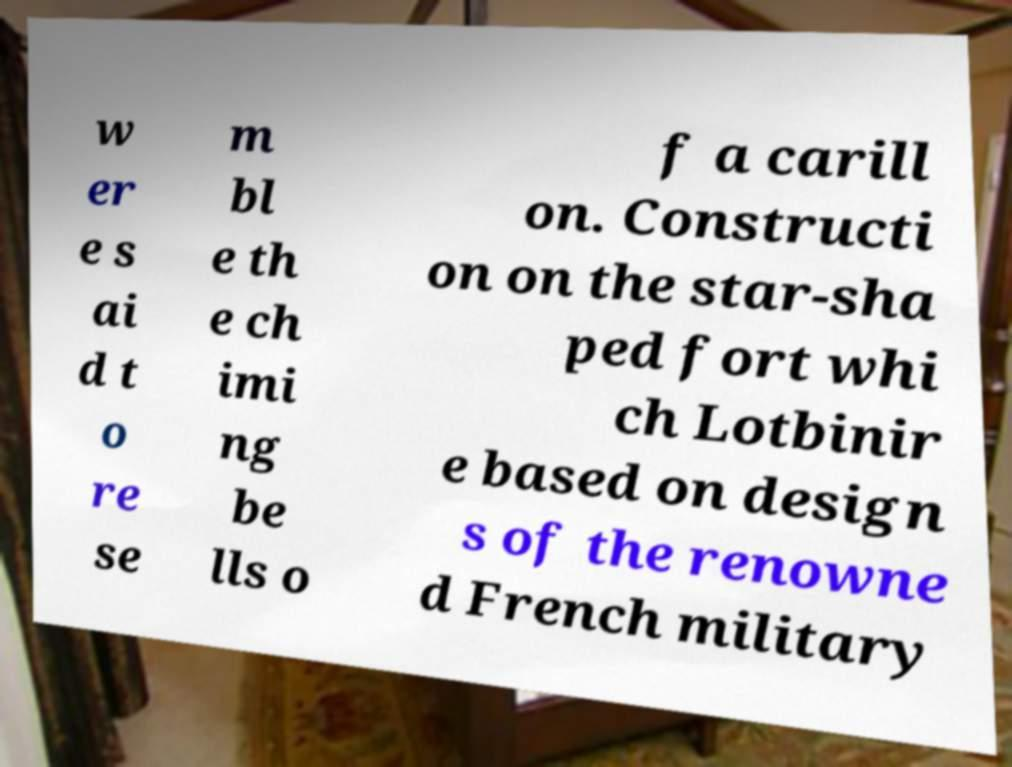Can you read and provide the text displayed in the image?This photo seems to have some interesting text. Can you extract and type it out for me? w er e s ai d t o re se m bl e th e ch imi ng be lls o f a carill on. Constructi on on the star-sha ped fort whi ch Lotbinir e based on design s of the renowne d French military 